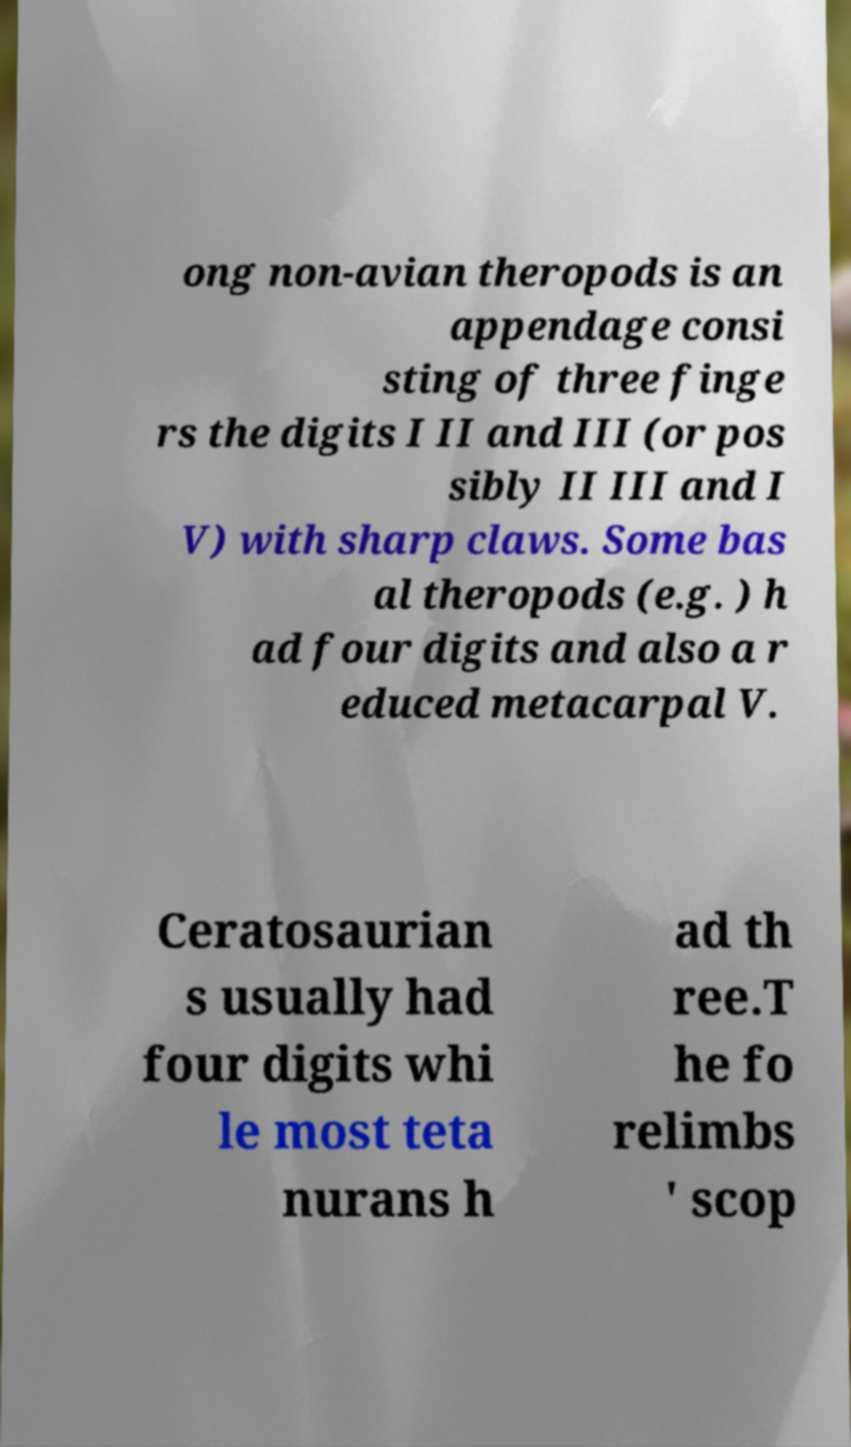Can you accurately transcribe the text from the provided image for me? ong non-avian theropods is an appendage consi sting of three finge rs the digits I II and III (or pos sibly II III and I V) with sharp claws. Some bas al theropods (e.g. ) h ad four digits and also a r educed metacarpal V. Ceratosaurian s usually had four digits whi le most teta nurans h ad th ree.T he fo relimbs ' scop 